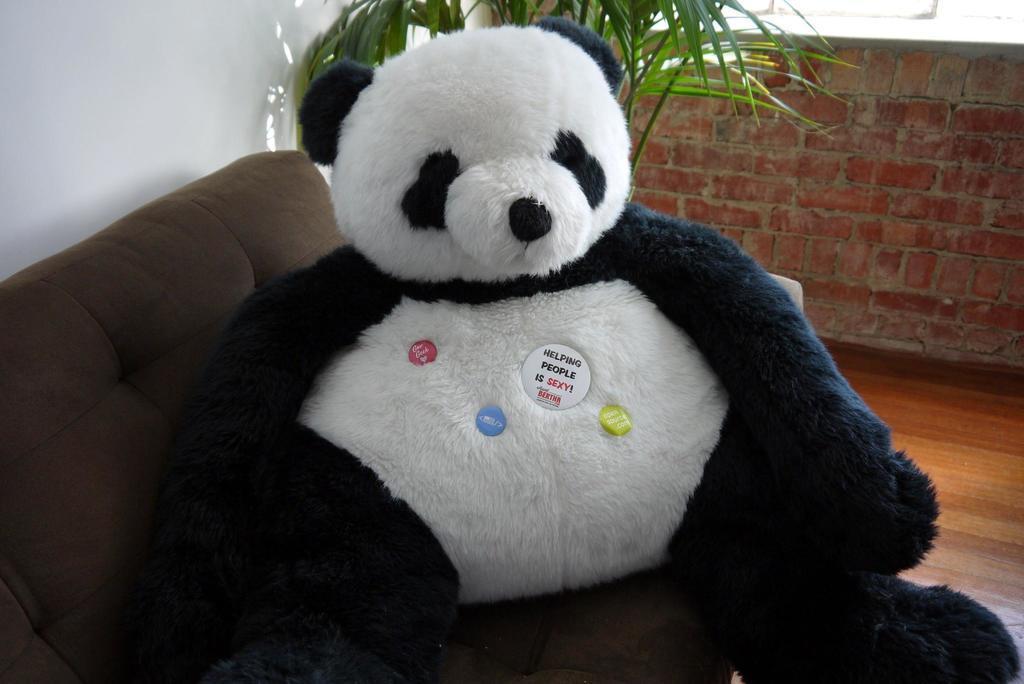Please provide a concise description of this image. There is a teddy bear present on the sofa which is at the bottom of this image. We can see a plant and a wall in the background. 